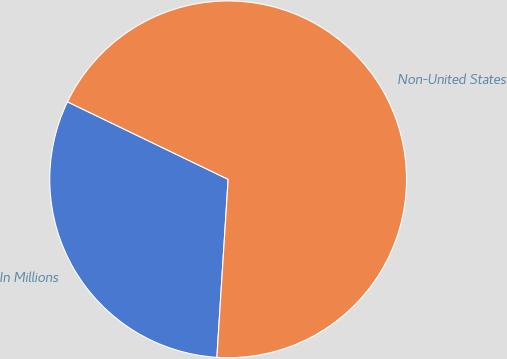<chart> <loc_0><loc_0><loc_500><loc_500><pie_chart><fcel>In Millions<fcel>Non-United States<nl><fcel>31.15%<fcel>68.85%<nl></chart> 